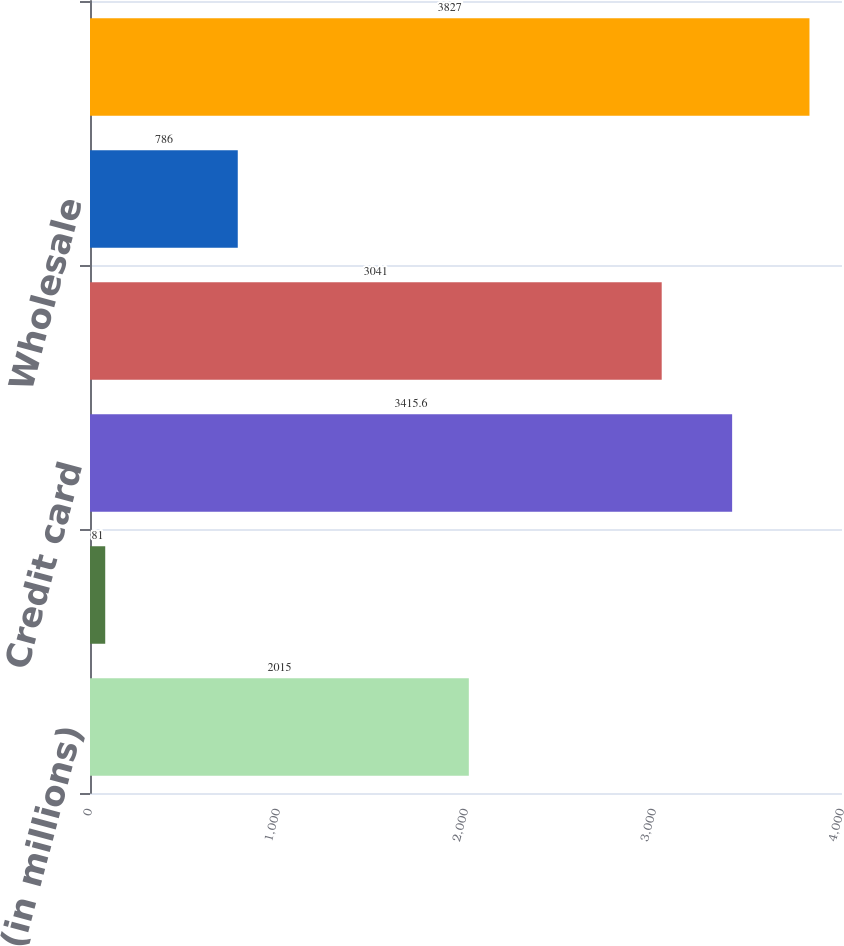<chart> <loc_0><loc_0><loc_500><loc_500><bar_chart><fcel>(in millions)<fcel>Consumer excluding credit card<fcel>Credit card<fcel>Total consumer<fcel>Wholesale<fcel>Total provision for credit<nl><fcel>2015<fcel>81<fcel>3415.6<fcel>3041<fcel>786<fcel>3827<nl></chart> 